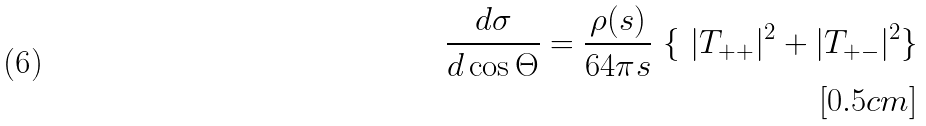Convert formula to latex. <formula><loc_0><loc_0><loc_500><loc_500>\frac { d \sigma } { d \cos \Theta } = \frac { \rho ( s ) } { 6 4 \pi s } \ \{ \ | T _ { + + } | ^ { 2 } + | T _ { + - } | ^ { 2 } \} \\ [ 0 . 5 c m ]</formula> 